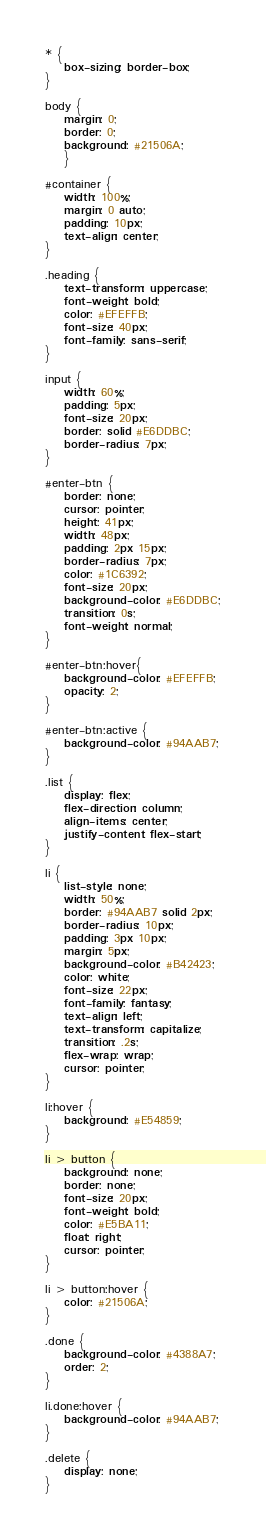<code> <loc_0><loc_0><loc_500><loc_500><_CSS_>* {
	box-sizing: border-box;
}

body {
	margin: 0;
	border: 0;
	background: #21506A;
	}

#container {
	width: 100%;
	margin: 0 auto;
	padding: 10px;
	text-align: center;
}

.heading {
	text-transform: uppercase;
	font-weight: bold;
	color: #EFEFFB;
	font-size: 40px;
	font-family: sans-serif;
}

input {
	width: 60%;
	padding: 5px;
	font-size: 20px;
	border: solid #E6DDBC;
	border-radius: 7px;
}

#enter-btn {
	border: none;
	cursor: pointer;
	height: 41px;
	width: 48px;
	padding: 2px 15px;
	border-radius: 7px;
	color: #1C6392;
	font-size: 20px;
	background-color: #E6DDBC;
	transition: 0s;
	font-weight: normal;
}

#enter-btn:hover{
	background-color: #EFEFFB;
	opacity: 2;
}

#enter-btn:active {
	background-color: #94AAB7;
}

.list {
	display: flex;
	flex-direction: column;
	align-items: center;
	justify-content: flex-start;
}

li {
	list-style: none;
	width: 50%;
	border: #94AAB7 solid 2px;
	border-radius: 10px;
	padding: 3px 10px;
	margin: 5px;
	background-color: #B42423;
	color: white;
	font-size: 22px;
	font-family: fantasy;
	text-align: left;
	text-transform: capitalize;
	transition: .2s;
	flex-wrap: wrap;
	cursor: pointer;
}

li:hover {
	background: #E54859;
}

li > button {
	background: none;
	border: none;
	font-size: 20px;
	font-weight: bold;
	color: #E5BA11;
	float: right;
	cursor: pointer;
}

li > button:hover {
	color: #21506A;
}

.done {
	background-color: #4388A7;
	order: 2;
}

li.done:hover {
	background-color: #94AAB7;
}

.delete {
	display: none;
}</code> 